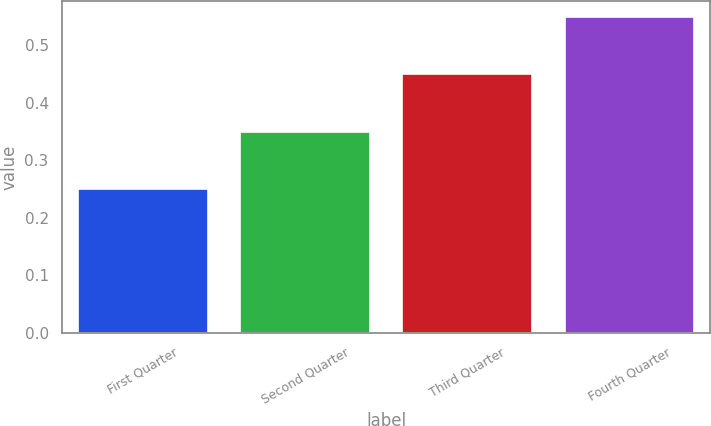Convert chart. <chart><loc_0><loc_0><loc_500><loc_500><bar_chart><fcel>First Quarter<fcel>Second Quarter<fcel>Third Quarter<fcel>Fourth Quarter<nl><fcel>0.25<fcel>0.35<fcel>0.45<fcel>0.55<nl></chart> 